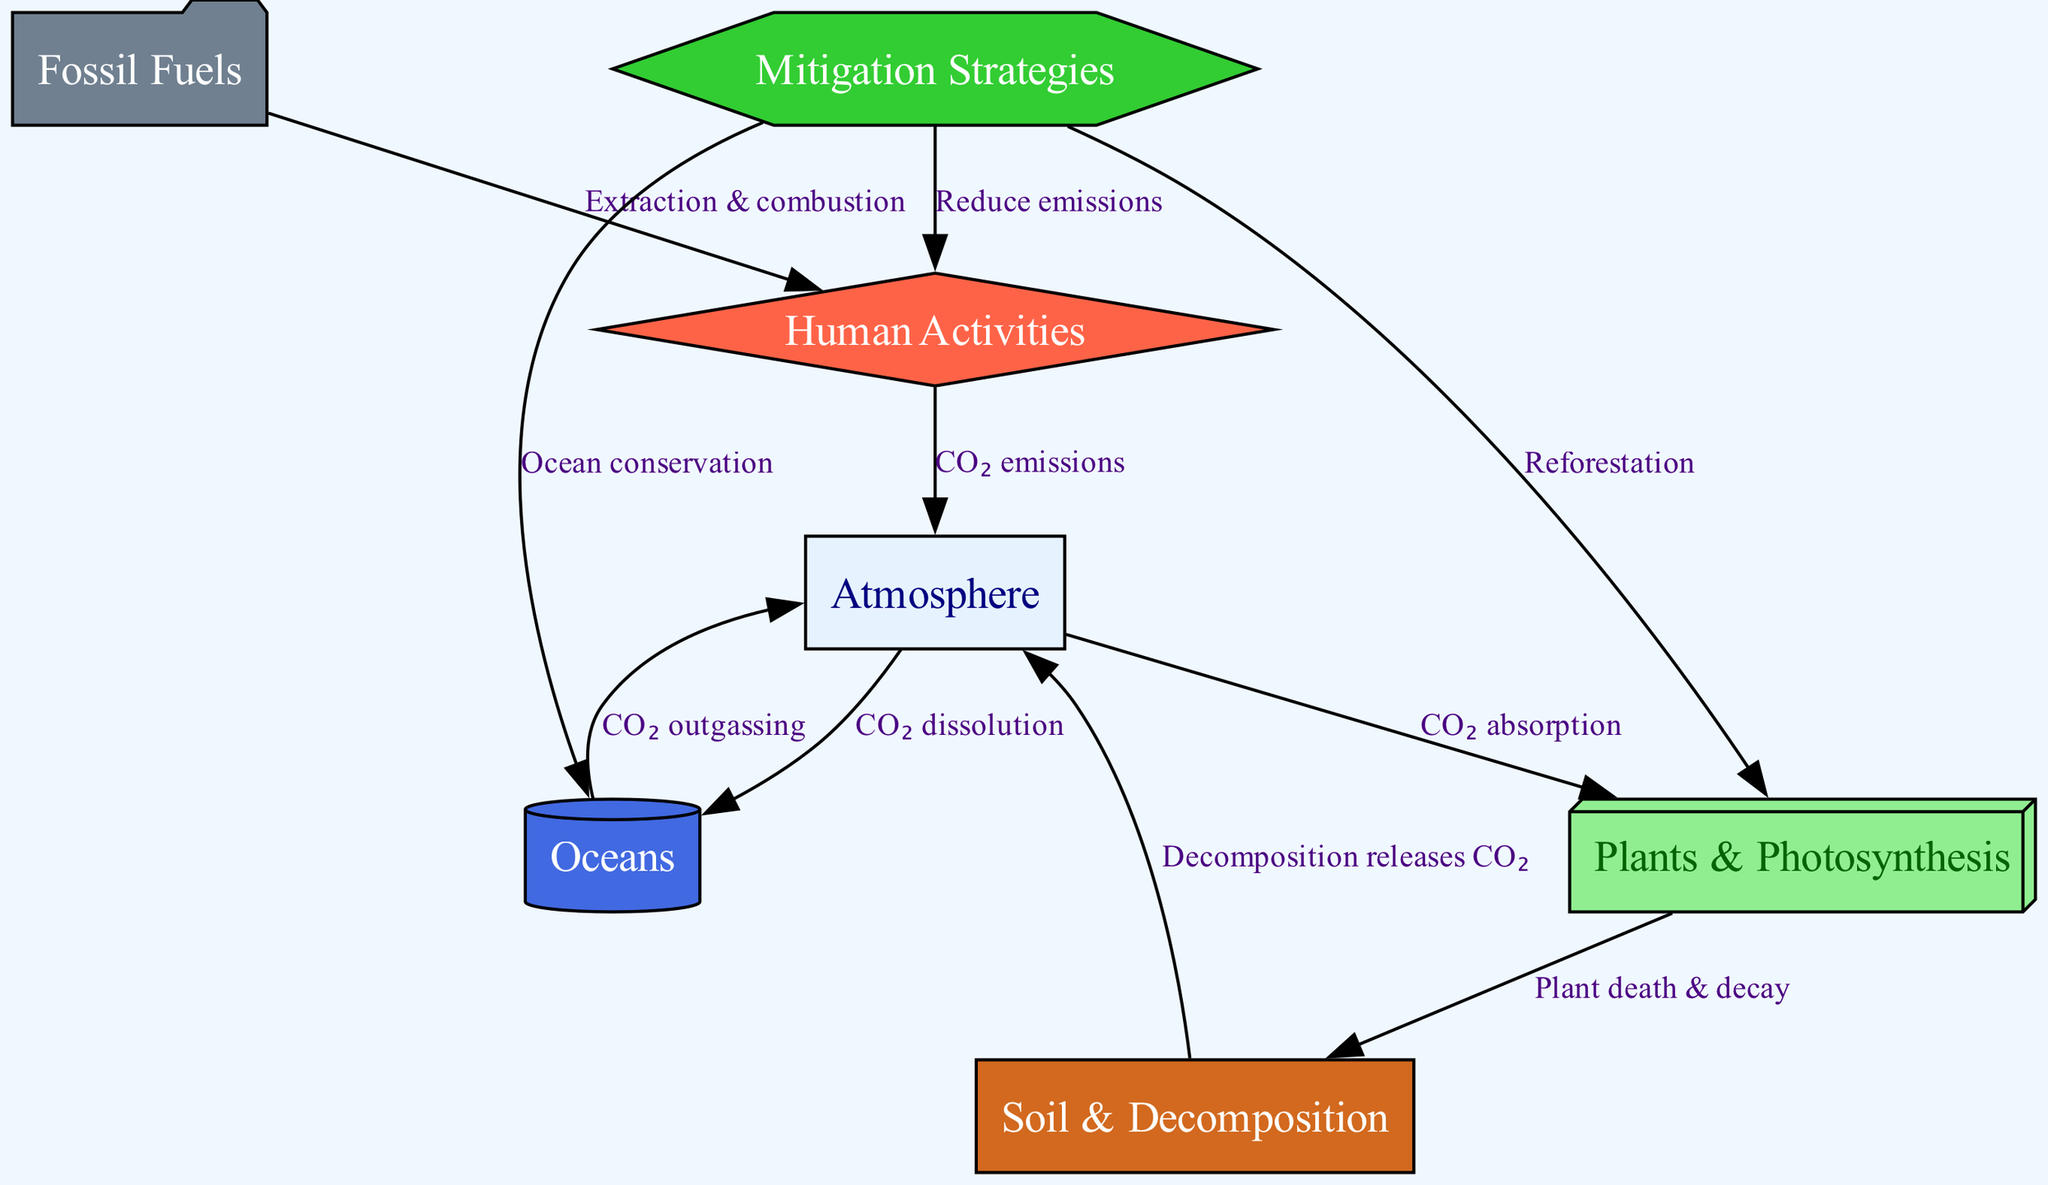What are the three main elements in the carbon cycle depicted in the diagram? The diagram includes three primary nodes: atmosphere, plants, and soil, which represent significant components of the carbon cycle where carbon moves through.
Answer: atmosphere, plants, soil How many nodes are present in the diagram? The diagram lists seven distinct nodes: atmosphere, plants, soil, oceans, fossil fuels, human activities, and mitigation strategies, which makes a total of seven.
Answer: seven What is the relationship between the atmosphere and plants? The edge between the atmosphere and plants is labeled "CO₂ absorption," indicating that carbon dioxide is absorbed by plants from the atmosphere.
Answer: CO₂ absorption Which node is directly impacted by human activities? The edge labeled "CO₂ emissions" signifies that human activities directly influence the atmosphere by releasing carbon dioxide into it.
Answer: atmosphere What mitigation strategy is associated with the oceans? The connection from mitigation to oceans is labeled "Ocean conservation," suggesting that one strategy for reducing carbon levels involves maintaining healthy oceans.
Answer: Ocean conservation What process occurs when plants die and decay? The relationship between plants and soil is described as "Plant death & decay," which signifies that the decomposition of dead plants contributes to carbon release into the soil and atmosphere.
Answer: Plant death & decay Which node receives carbon from fossil fuels? The diagram shows that carbon from fossil fuels is directed towards human activities through the edge labeled "Extraction & combustion," indicating a flow of carbon.
Answer: human activities How does the soil affect the atmosphere? The edge between soil and atmosphere is labeled "Decomposition releases CO₂," illustrating that the process of decomposition in the soil results in the release of carbon dioxide into the atmosphere.
Answer: Decomposition releases CO₂ What connection supports reforestation as a mitigation strategy? The mitigation node has an edge directed towards plants, labeled "Reforestation," which indicates that reforesting areas can enhance carbon absorption in plants.
Answer: Reforestation 